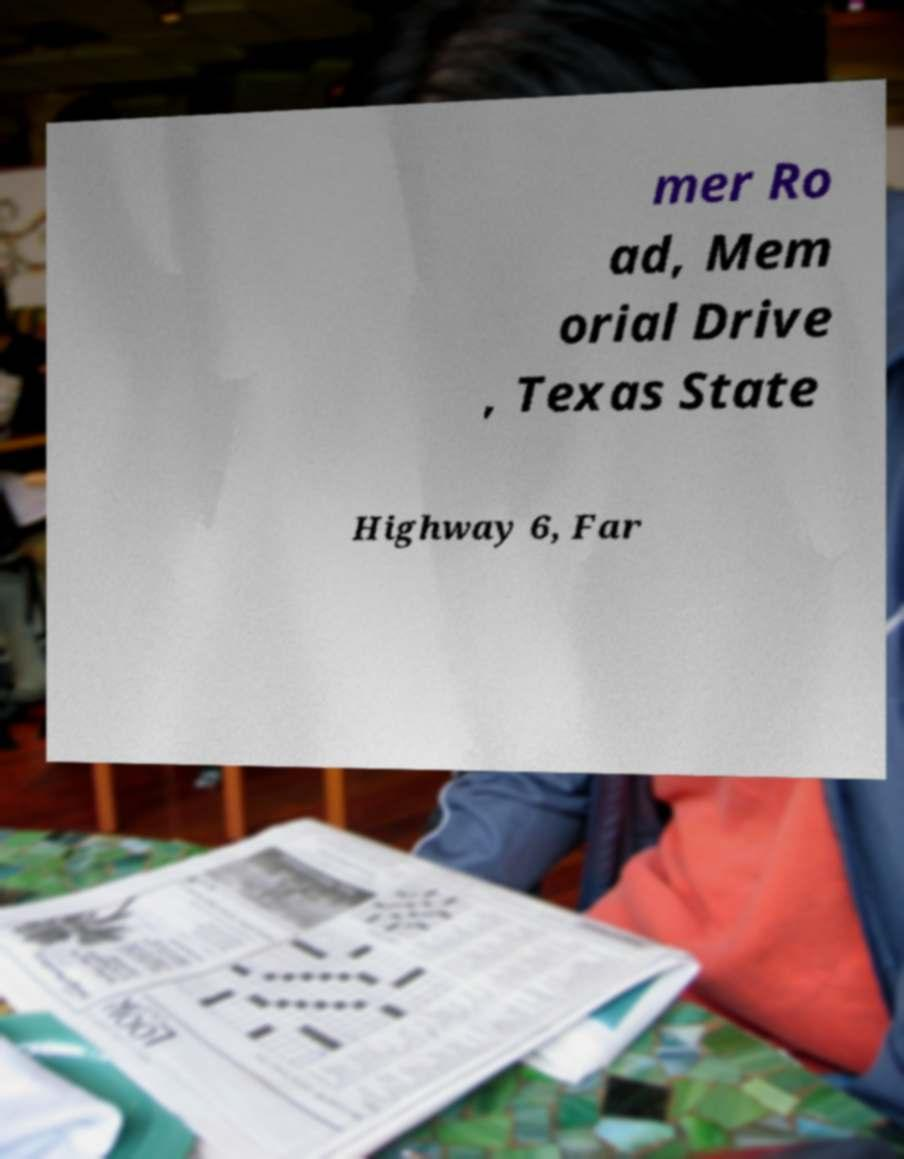I need the written content from this picture converted into text. Can you do that? mer Ro ad, Mem orial Drive , Texas State Highway 6, Far 